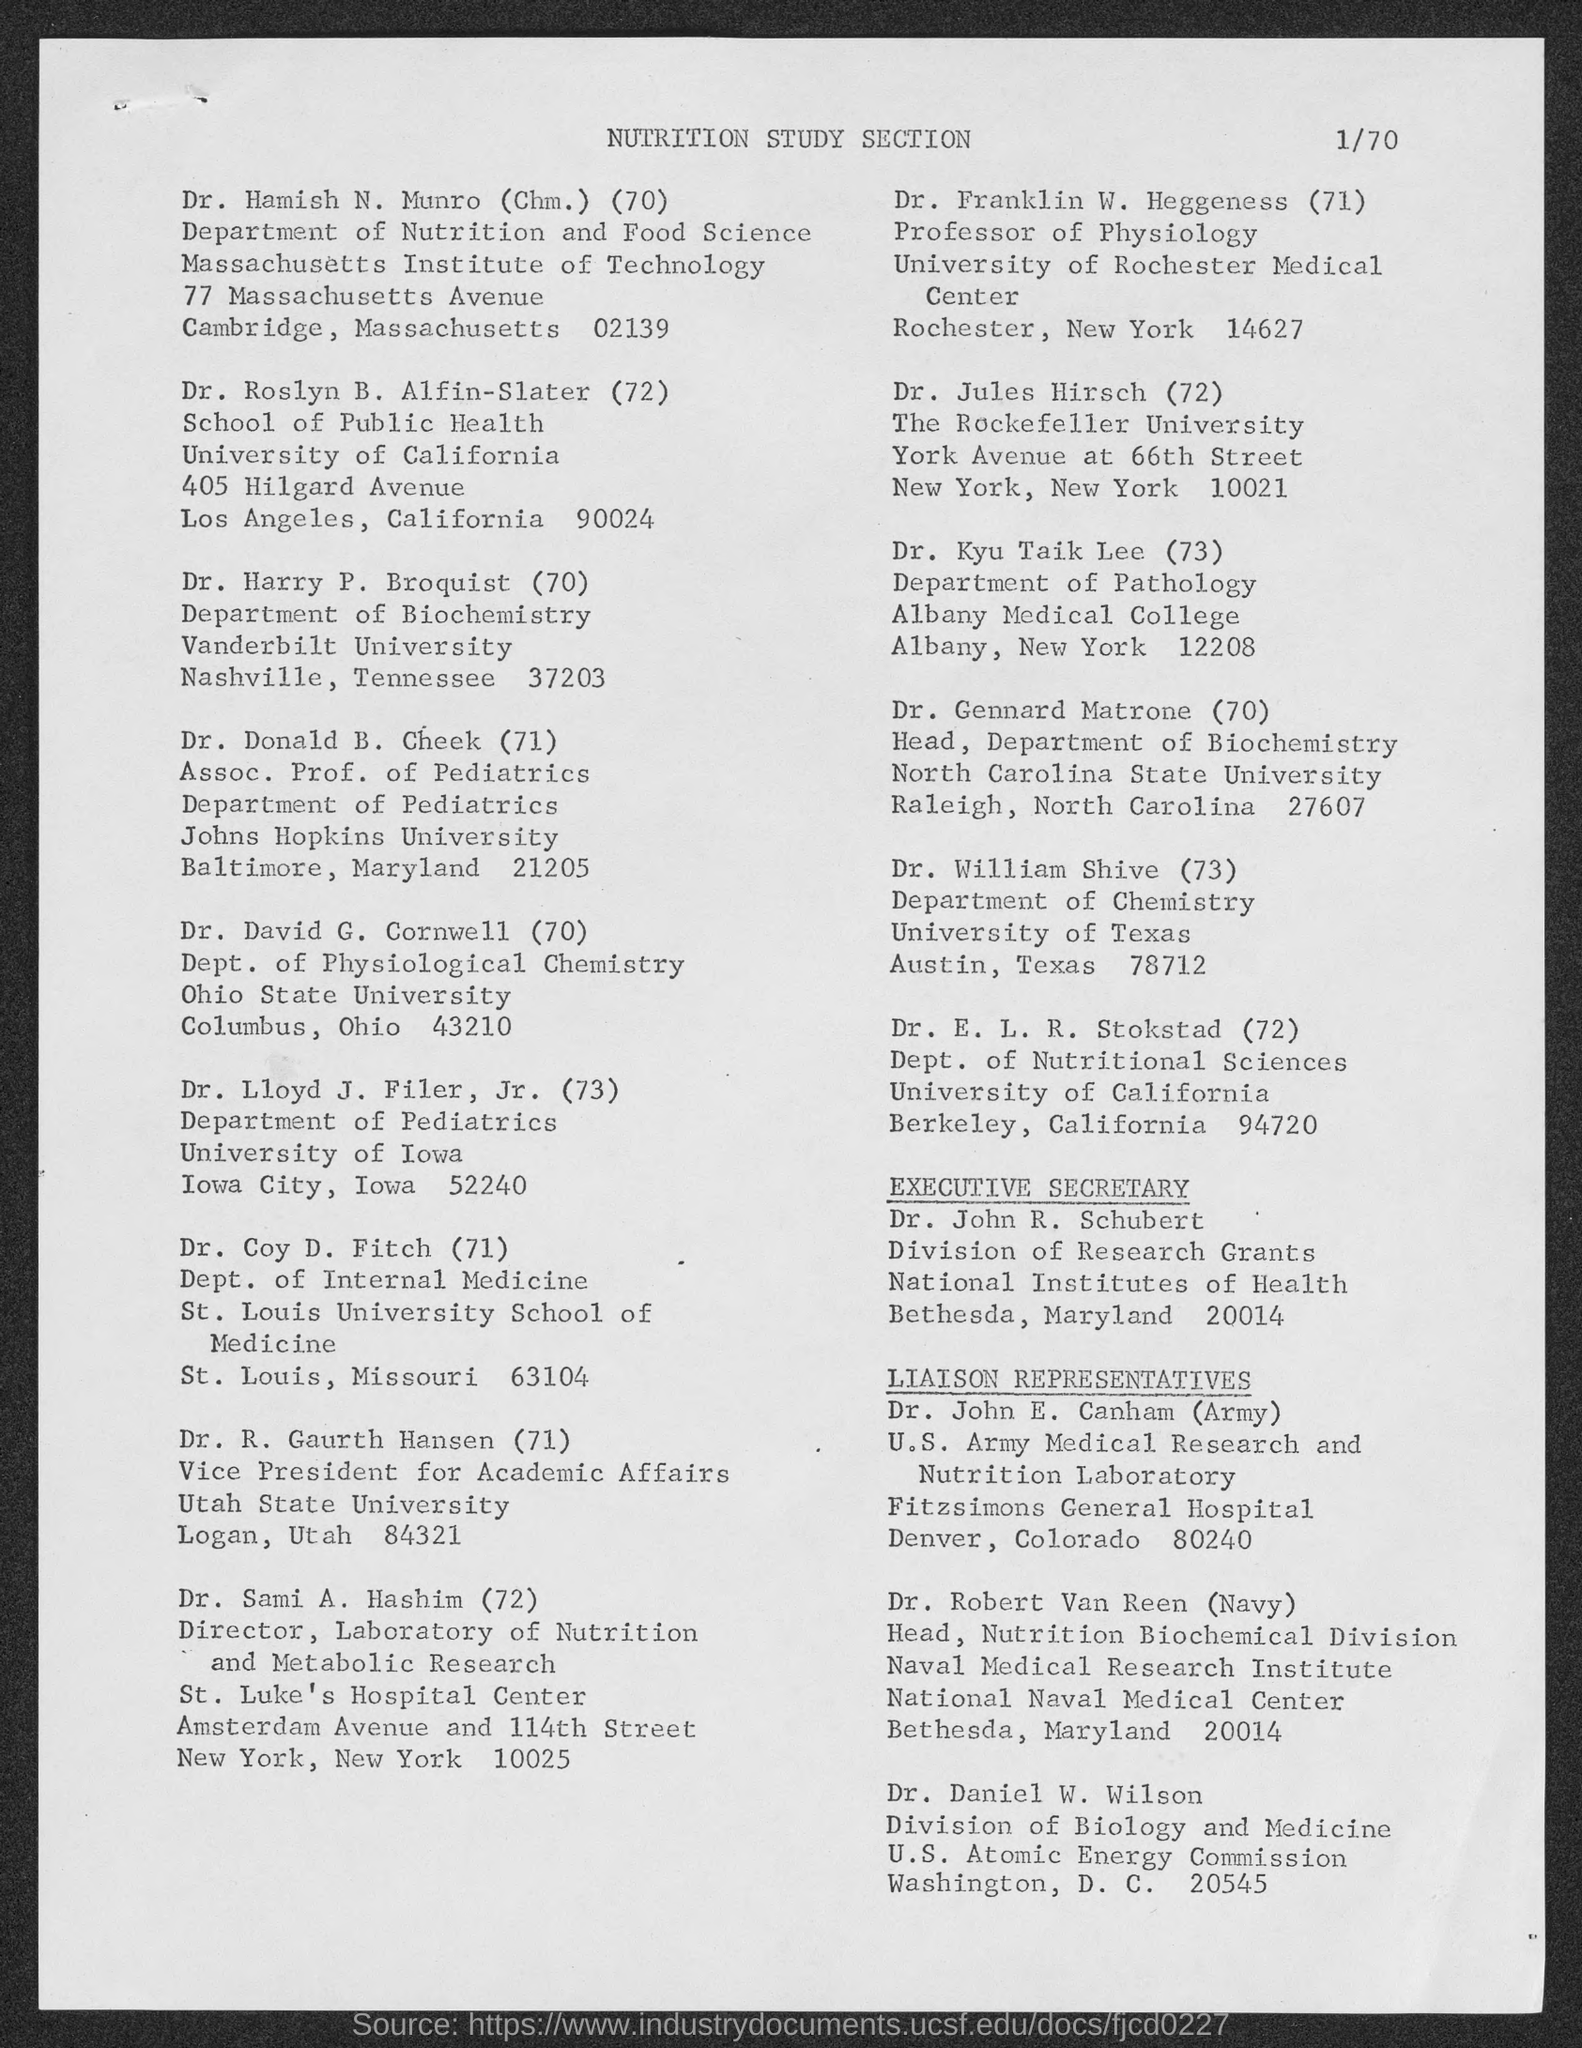Which department does Dr. Hamish N. Munro belong to?
Your answer should be compact. Department of Nutrition and Food Science. Who is the executive secretary?
Your response must be concise. Dr. John R. Schubert. From which college is Dr. Kyu Taik Lee?
Offer a very short reply. Albany medical college. 